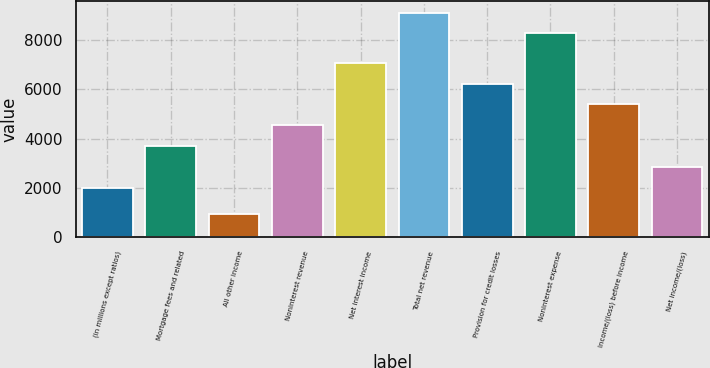<chart> <loc_0><loc_0><loc_500><loc_500><bar_chart><fcel>(in millions except ratios)<fcel>Mortgage fees and related<fcel>All other income<fcel>Noninterest revenue<fcel>Net interest income<fcel>Total net revenue<fcel>Provision for credit losses<fcel>Noninterest expense<fcel>Income/(loss) before income<fcel>Net income/(loss)<nl><fcel>2011<fcel>3697.2<fcel>940.1<fcel>4540.3<fcel>7069.6<fcel>9099.1<fcel>6226.5<fcel>8256<fcel>5383.4<fcel>2854.1<nl></chart> 